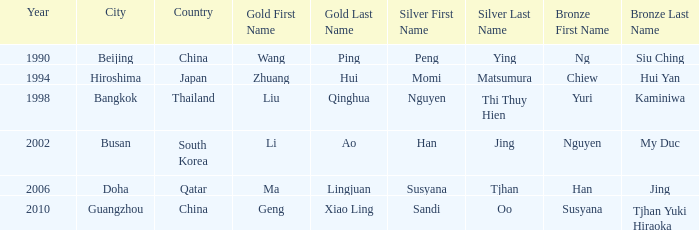Parse the table in full. {'header': ['Year', 'City', 'Country', 'Gold First Name', 'Gold Last Name', 'Silver First Name', 'Silver Last Name', 'Bronze First Name', 'Bronze Last Name'], 'rows': [['1990', 'Beijing', 'China', 'Wang', 'Ping', 'Peng', 'Ying', 'Ng', 'Siu Ching'], ['1994', 'Hiroshima', 'Japan', 'Zhuang', 'Hui', 'Momi', 'Matsumura', 'Chiew', 'Hui Yan'], ['1998', 'Bangkok', 'Thailand', 'Liu', 'Qinghua', 'Nguyen', 'Thi Thuy Hien', 'Yuri', 'Kaminiwa'], ['2002', 'Busan', 'South Korea', 'Li', 'Ao', 'Han', 'Jing', 'Nguyen', 'My Duc'], ['2006', 'Doha', 'Qatar', 'Ma', 'Lingjuan', 'Susyana', 'Tjhan', 'Han', 'Jing'], ['2010', 'Guangzhou', 'China', 'Geng', 'Xiao Ling', 'Sandi', 'Oo', 'Susyana', 'Tjhan Yuki Hiraoka']]} What's the Bronze with the Year of 1998? Yuri Kaminiwa. 